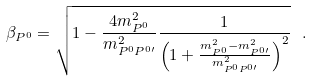<formula> <loc_0><loc_0><loc_500><loc_500>\beta _ { P ^ { 0 } } = \sqrt { 1 - \frac { 4 m ^ { 2 } _ { P ^ { 0 } } } { m ^ { 2 } _ { P ^ { 0 } P ^ { 0 \prime } } } \frac { 1 } { \left ( 1 + \frac { m ^ { 2 } _ { P ^ { 0 } } - m ^ { 2 } _ { P ^ { 0 \prime } } } { m ^ { 2 } _ { P ^ { 0 } P ^ { 0 \prime } } } \right ) ^ { 2 } } } \ .</formula> 